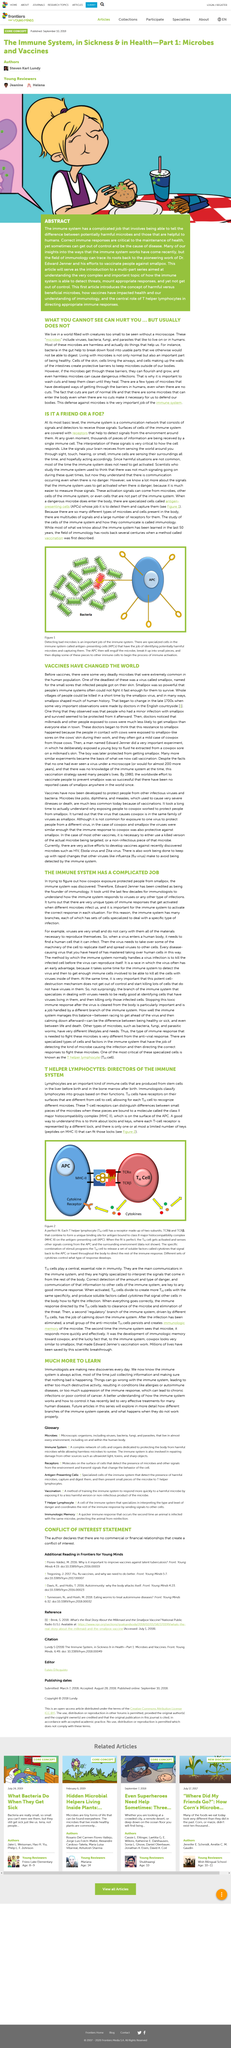Highlight a few significant elements in this photo. Antigen-presenting cells, commonly referred to as APCs, play a crucial role in the immune system by presenting antigens to T cells. The type of response that develops is controlled by the different sets of cytokines that are present. In Figure 1, the antigen-presenting cell (APC) is depicted engulfing a harmful microbe. What will it do next? It will break down the microbe into smaller pieces and display some of these fragments to other immune cells. Receptors on Th cells are important as they enable each Th cell to recognize different microbes, thereby playing a crucial role in immune response. Smallpox was one of the deadliest viruses before the development of vaccines. 